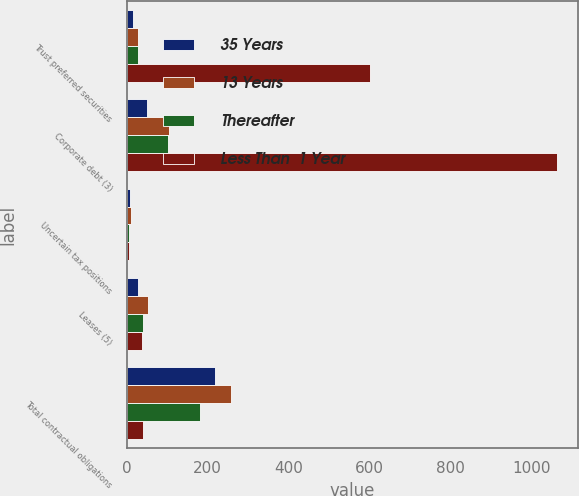Convert chart to OTSL. <chart><loc_0><loc_0><loc_500><loc_500><stacked_bar_chart><ecel><fcel>Trust preferred securities<fcel>Corporate debt (3)<fcel>Uncertain tax positions<fcel>Leases (5)<fcel>Total contractual obligations<nl><fcel>35 Years<fcel>15<fcel>50<fcel>7<fcel>27<fcel>218<nl><fcel>13 Years<fcel>29<fcel>104<fcel>10<fcel>53<fcel>258<nl><fcel>Thereafter<fcel>29<fcel>101<fcel>6<fcel>39<fcel>182<nl><fcel>Less Than  1 Year<fcel>601<fcel>1062<fcel>5<fcel>37<fcel>39<nl></chart> 